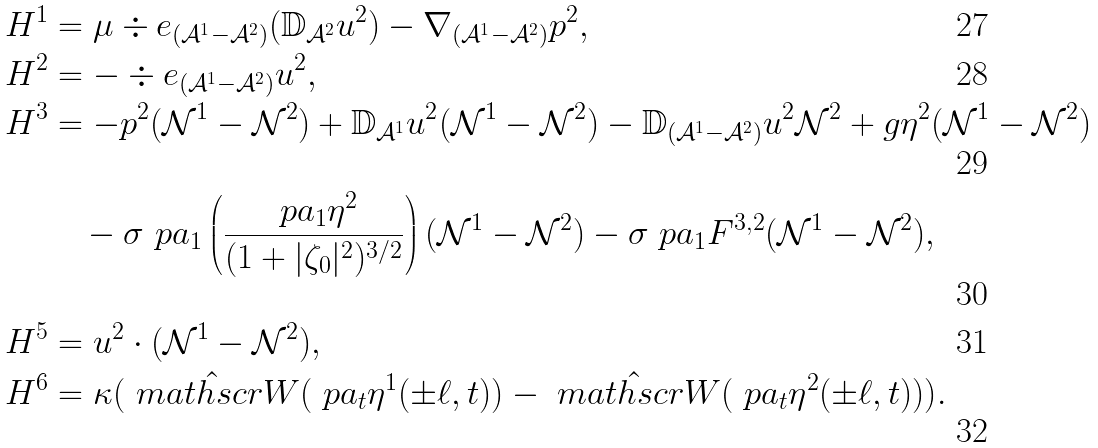Convert formula to latex. <formula><loc_0><loc_0><loc_500><loc_500>H ^ { 1 } & = \mu \div e _ { ( \mathcal { A } ^ { 1 } - \mathcal { A } ^ { 2 } ) } ( \mathbb { D } _ { \mathcal { A } ^ { 2 } } u ^ { 2 } ) - \nabla _ { ( \mathcal { A } ^ { 1 } - \mathcal { A } ^ { 2 } ) } p ^ { 2 } , \\ H ^ { 2 } & = - \div e _ { ( \mathcal { A } ^ { 1 } - \mathcal { A } ^ { 2 } ) } u ^ { 2 } , \\ H ^ { 3 } & = - p ^ { 2 } ( \mathcal { N } ^ { 1 } - \mathcal { N } ^ { 2 } ) + \mathbb { D } _ { \mathcal { A } ^ { 1 } } u ^ { 2 } ( \mathcal { N } ^ { 1 } - \mathcal { N } ^ { 2 } ) - \mathbb { D } _ { ( \mathcal { A } ^ { 1 } - \mathcal { A } ^ { 2 } ) } u ^ { 2 } \mathcal { N } ^ { 2 } + g \eta ^ { 2 } ( \mathcal { N } ^ { 1 } - \mathcal { N } ^ { 2 } ) \\ & \quad - \sigma \ p a _ { 1 } \left ( \frac { \ p a _ { 1 } \eta ^ { 2 } } { ( 1 + | \zeta _ { 0 } | ^ { 2 } ) ^ { 3 / 2 } } \right ) ( \mathcal { N } ^ { 1 } - \mathcal { N } ^ { 2 } ) - \sigma \ p a _ { 1 } F ^ { 3 , 2 } ( \mathcal { N } ^ { 1 } - \mathcal { N } ^ { 2 } ) , \\ H ^ { 5 } & = u ^ { 2 } \cdot ( \mathcal { N } ^ { 1 } - \mathcal { N } ^ { 2 } ) , \\ H ^ { 6 } & = \kappa ( \hat { \ m a t h s c r { W } } ( \ p a _ { t } \eta ^ { 1 } ( \pm \ell , t ) ) - \hat { \ m a t h s c r { W } } ( \ p a _ { t } \eta ^ { 2 } ( \pm \ell , t ) ) ) .</formula> 